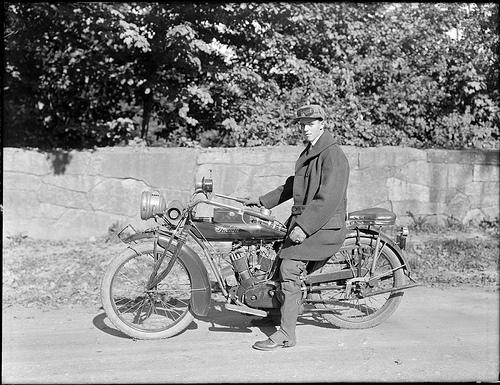How many bikes are shown?
Short answer required. 1. Is he selling something?
Quick response, please. No. What is this person sitting on?
Write a very short answer. Motorcycle. How many bikes?
Give a very brief answer. 1. Does this photo show more than one person?
Concise answer only. No. What mode of transportation is the woman using?
Give a very brief answer. Motorcycle. Is this picture modern or old fashion?
Keep it brief. Old fashion. What year was the photo taken?
Answer briefly. 1945. Is this a daily mode of transportation?
Answer briefly. Yes. How fast is the bike moving?
Quick response, please. 0 mph. What type of bike is being showcased in this photo?
Concise answer only. Motorcycle. How many wheels are on the vehicle?
Write a very short answer. 2. Is the man selling goods?
Keep it brief. No. Is the man parking in front of a garage?
Short answer required. No. Where are the eyeglasses?
Be succinct. On hat. What type of shoes does the man have on?
Give a very brief answer. Boots. What type is the bike?
Short answer required. Motor. What is man doing on his cycle?
Quick response, please. Sitting. What is the man sitting on?
Give a very brief answer. Motorcycle. On what surface is the guy sitting?
Write a very short answer. Motorcycle. Are the wheels rubber?
Keep it brief. Yes. What is the motorized bike called?
Be succinct. Motorcycle. 